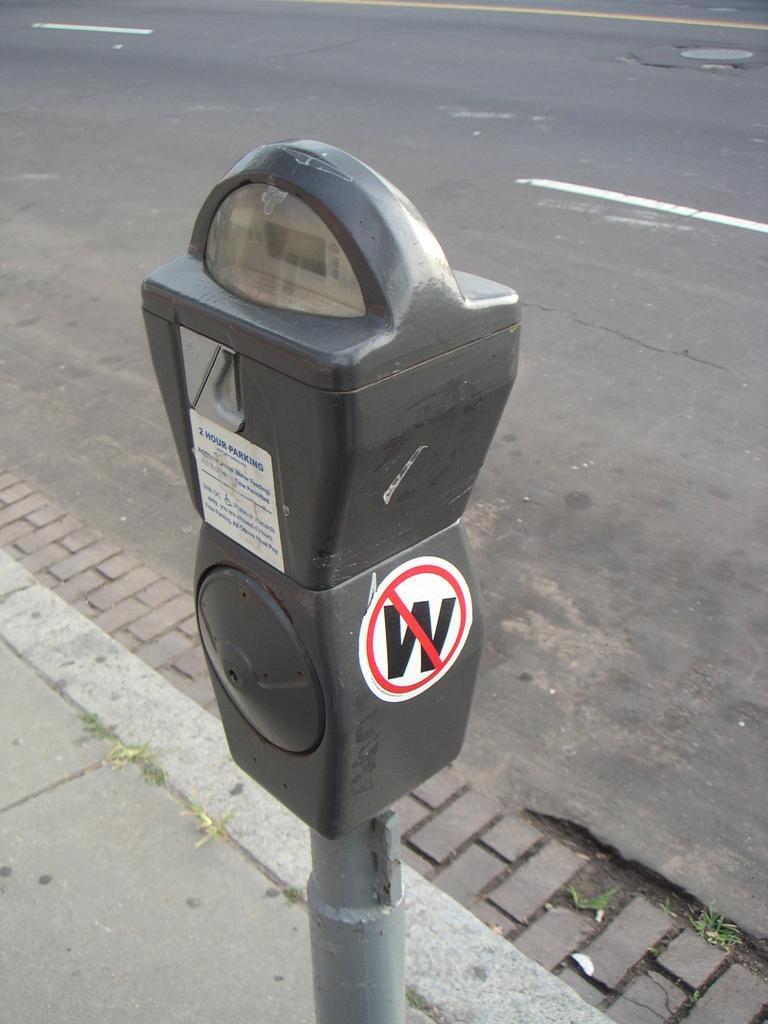How would you summarize this image in a sentence or two? In this picture there is a curb in the center of the image. 